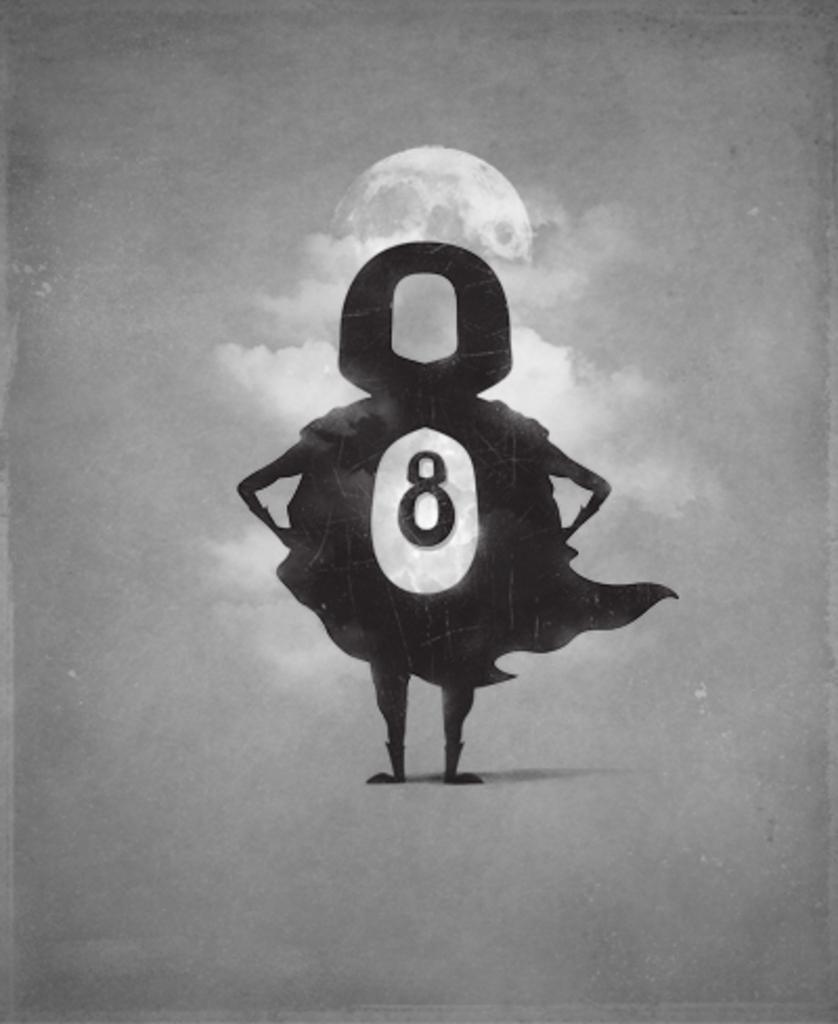How would you summarize this image in a sentence or two? This is the black and white image and in the middle of the image we can see the cartoon image and in the background, it looks like the sky. 